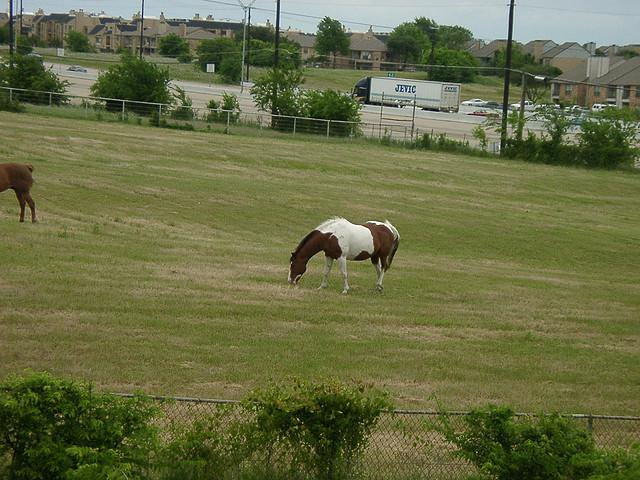What type of animals are present? Please explain your reasoning. horse. Horses are in the field. 